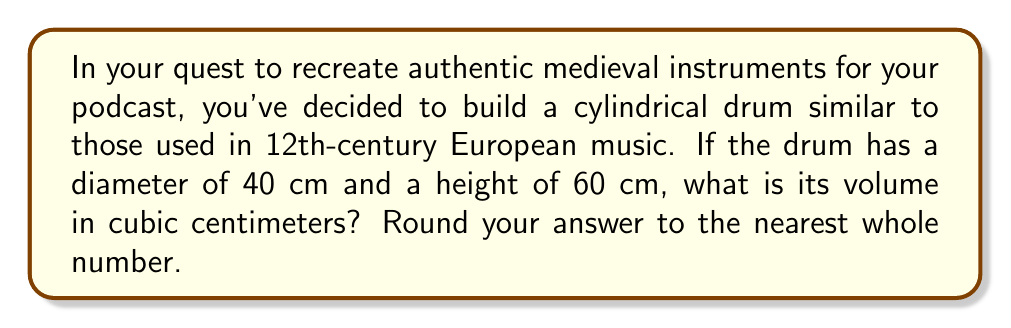Teach me how to tackle this problem. To calculate the volume of a cylindrical drum, we need to use the formula for the volume of a cylinder:

$$V = \pi r^2 h$$

Where:
$V$ = volume
$r$ = radius of the base
$h$ = height of the cylinder

Let's solve this step-by-step:

1. First, we need to find the radius. The diameter is given as 40 cm, so the radius is half of that:
   $r = 40 \text{ cm} \div 2 = 20 \text{ cm}$

2. We already know the height: $h = 60 \text{ cm}$

3. Now, let's plug these values into our formula:
   $$V = \pi (20 \text{ cm})^2 (60 \text{ cm})$$

4. Simplify the calculation:
   $$V = \pi (400 \text{ cm}^2) (60 \text{ cm})$$
   $$V = 24000\pi \text{ cm}^3$$

5. Use 3.14159 as an approximation for $\pi$:
   $$V \approx 24000 \times 3.14159 \text{ cm}^3$$
   $$V \approx 75398.16 \text{ cm}^3$$

6. Rounding to the nearest whole number:
   $$V \approx 75398 \text{ cm}^3$$
Answer: 75398 cm³ 